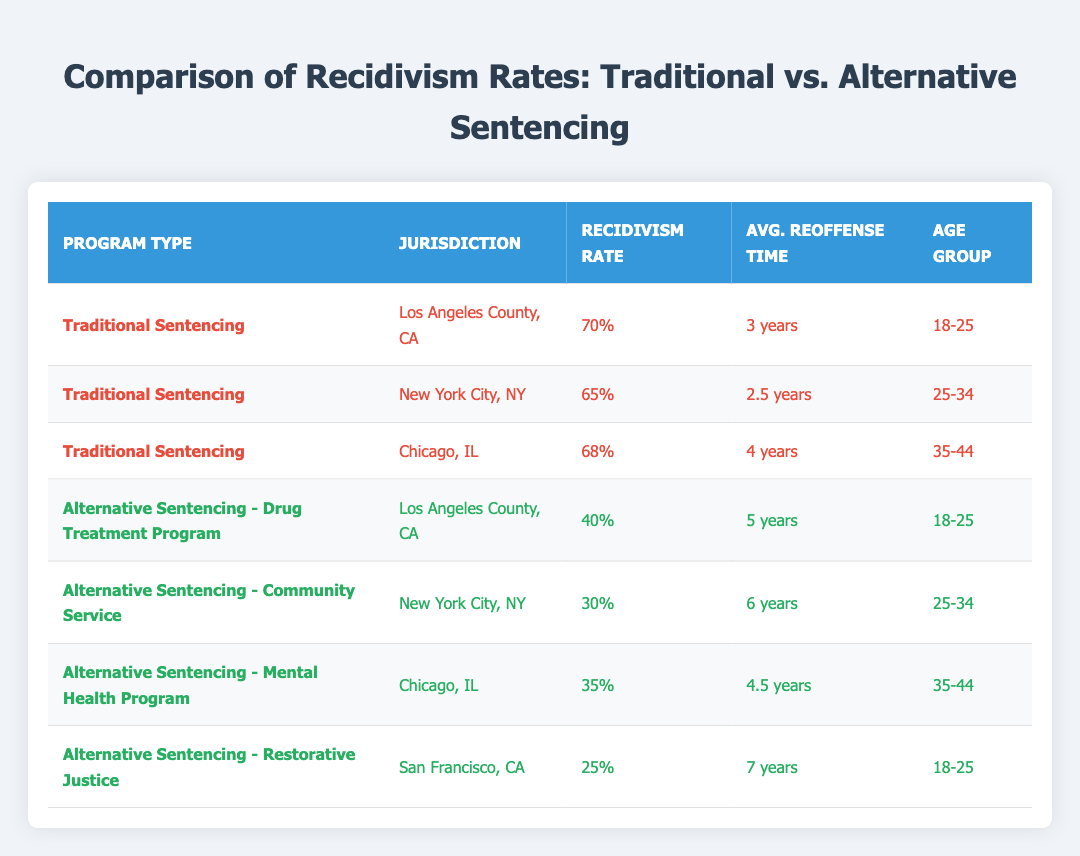What is the recidivism rate for the Alternative Sentencing - Restorative Justice program? The table shows that the recidivism rate for the Alternative Sentencing - Restorative Justice program in San Francisco, CA, is 25%.
Answer: 25% Which jurisdiction has the highest recidivism rate for traditional sentencing? According to the table, Los Angeles County, CA, has the highest recidivism rate for traditional sentencing at 70%.
Answer: Los Angeles County, CA What is the average reoffense time for individuals aged 25-34 in traditional sentencing? The average reoffense times for the 25-34 age group in traditional sentencing from New York City, NY, is 2.5 years.
Answer: 2.5 years How many programs listed have a recidivism rate lower than 40%? By examining the table, there are three programs with a recidivism rate lower than 40%: Community Service (30%), Mental Health Program (35%), and Restorative Justice (25%).
Answer: 3 Is the recidivism rate for the Traditional Sentencing program in Chicago higher than that of the Alternative Sentencing - Mental Health Program? Checking the table, the recidivism rate for Traditional Sentencing in Chicago is 68%, while for the Alternative Sentencing - Mental Health Program, it is 35%. Thus, it is true that Traditional Sentencing in Chicago is higher.
Answer: Yes What is the difference in recidivism rates between the Traditional Sentencing in New York City and the Alternative Sentencing - Community Service? The recidivism rate for Traditional Sentencing in New York City is 65%, while for Alternative Sentencing - Community Service, it is 30%. The difference is 65% - 30% = 35%.
Answer: 35% Which alternative program has the longest average reoffense time? The table indicates that the Alternative Sentencing - Restorative Justice program has the longest average reoffense time of 7 years.
Answer: 7 years If we consider the average recidivism rates for traditional and alternative sentencing programs, which one has a lower rate? The average recidivism rate for traditional sentencing (70% + 65% + 68% = 203% divided by 3 = 67.67%) is higher than that of alternative sentencing (40% + 30% + 35% + 25% = 130% divided by 4 = 32.5%). Therefore, alternative sentencing has a lower rate.
Answer: Alternative sentencing How does the average reoffense time compare between Traditional Sentencing and Alternative Sentencing programs across age groups? The average reoffense time for Traditional Sentencing programs is: 3 years (LA) + 2.5 years (NYC) + 4 years (Chicago) = 9.5 years, averaged across 3 = 3.17 years. For Alternative, it's 5 years (Drug Treatment) + 6 years (Community Service) + 4.5 years (Mental Health) + 7 years (Restorative Justice) = 22.5 years, averaged across 4 = 5.63 years. Alternative programs show longer reoffense times compared to Traditional.
Answer: Alternative sentencing has longer reoffense time 